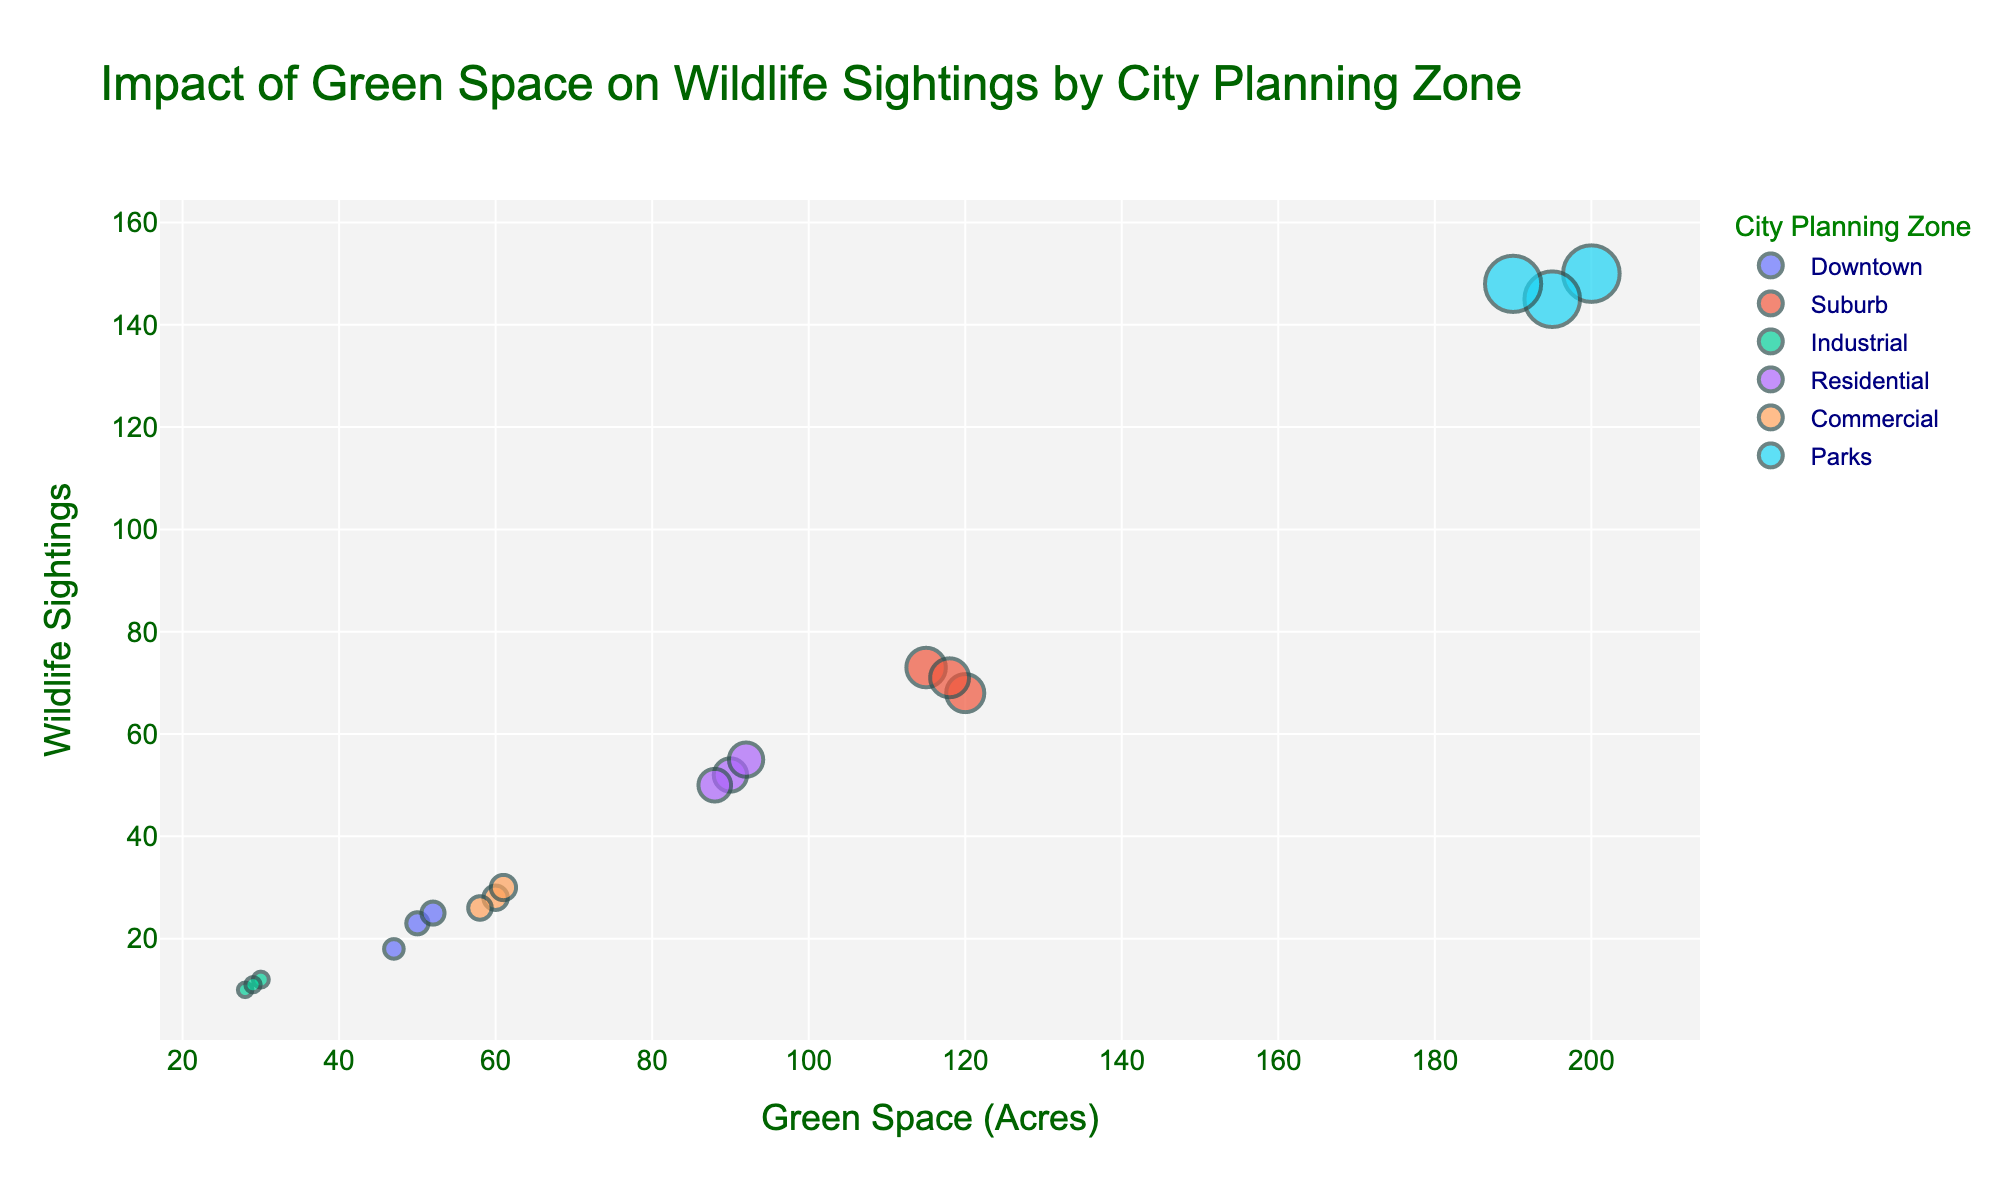What's the title of the figure? The title is typically found at the top of the figure. In this case, it is "Impact of Green Space on Wildlife Sightings by City Planning Zone".
Answer: Impact of Green Space on Wildlife Sightings by City Planning Zone What are the axes titles? The axes titles are usually labeled along the x-axis and y-axis. For this figure, the x-axis is labeled "Green Space (Acres)", and the y-axis is labeled "Wildlife Sightings".
Answer: Green Space (Acres) and Wildlife Sightings Which city planning zone has the highest median wildlife sightings? Look at the data points for each city planning zone and identify their median values. Parks have the highest median wildlife sightings, as all its data points are consistently high.
Answer: Parks How many data points are represented for the 'Commercial' zone? Count the number of data points that are colored or labeled as 'Commercial'. There are three data points for 'Commercial'.
Answer: 3 Which city planning zone has the largest range of green space? Identify the maximum and minimum values of green space for each city planning zone and calculate the range. The 'Parks' zone has the largest range, from 190 to 200 acres.
Answer: Parks What's the average number of wildlife sightings in the 'Suburb' zone? Calculate the average of the data points for wildlife sightings in the 'Suburb' zone. Sum of sightings: 68 + 73 + 71 = 212. Divide by the number of data points: 212/3 = 70.67
Answer: 70.67 Do zones with more green space tend to have more wildlife sightings? Compare the overall trend across different zones on how green space correlates with wildlife sightings. Generally, zones with more green space, like 'Parks', also have more wildlife sightings.
Answer: Yes Which city planning zone has the smallest size marker in the plot? This can be inferred by looking at the marker sizes representing wildlife sightings. The 'Industrial' zone has the smallest wildlife sightings markers.
Answer: Industrial How does the 'Residential' zone compare with the 'Downtown' zone in terms of wildlife sightings? Compare the wildlife sightings data points of the 'Residential' and 'Downtown' zones. 'Residential' has more wildlife sightings on average.
Answer: Residential has more Which city planning zone has the midpoint green space of 60 acres? Find the data points and their corresponding zones where the green space is around 60 acres. 'Commercial' fits this criterion the most.
Answer: Commercial 